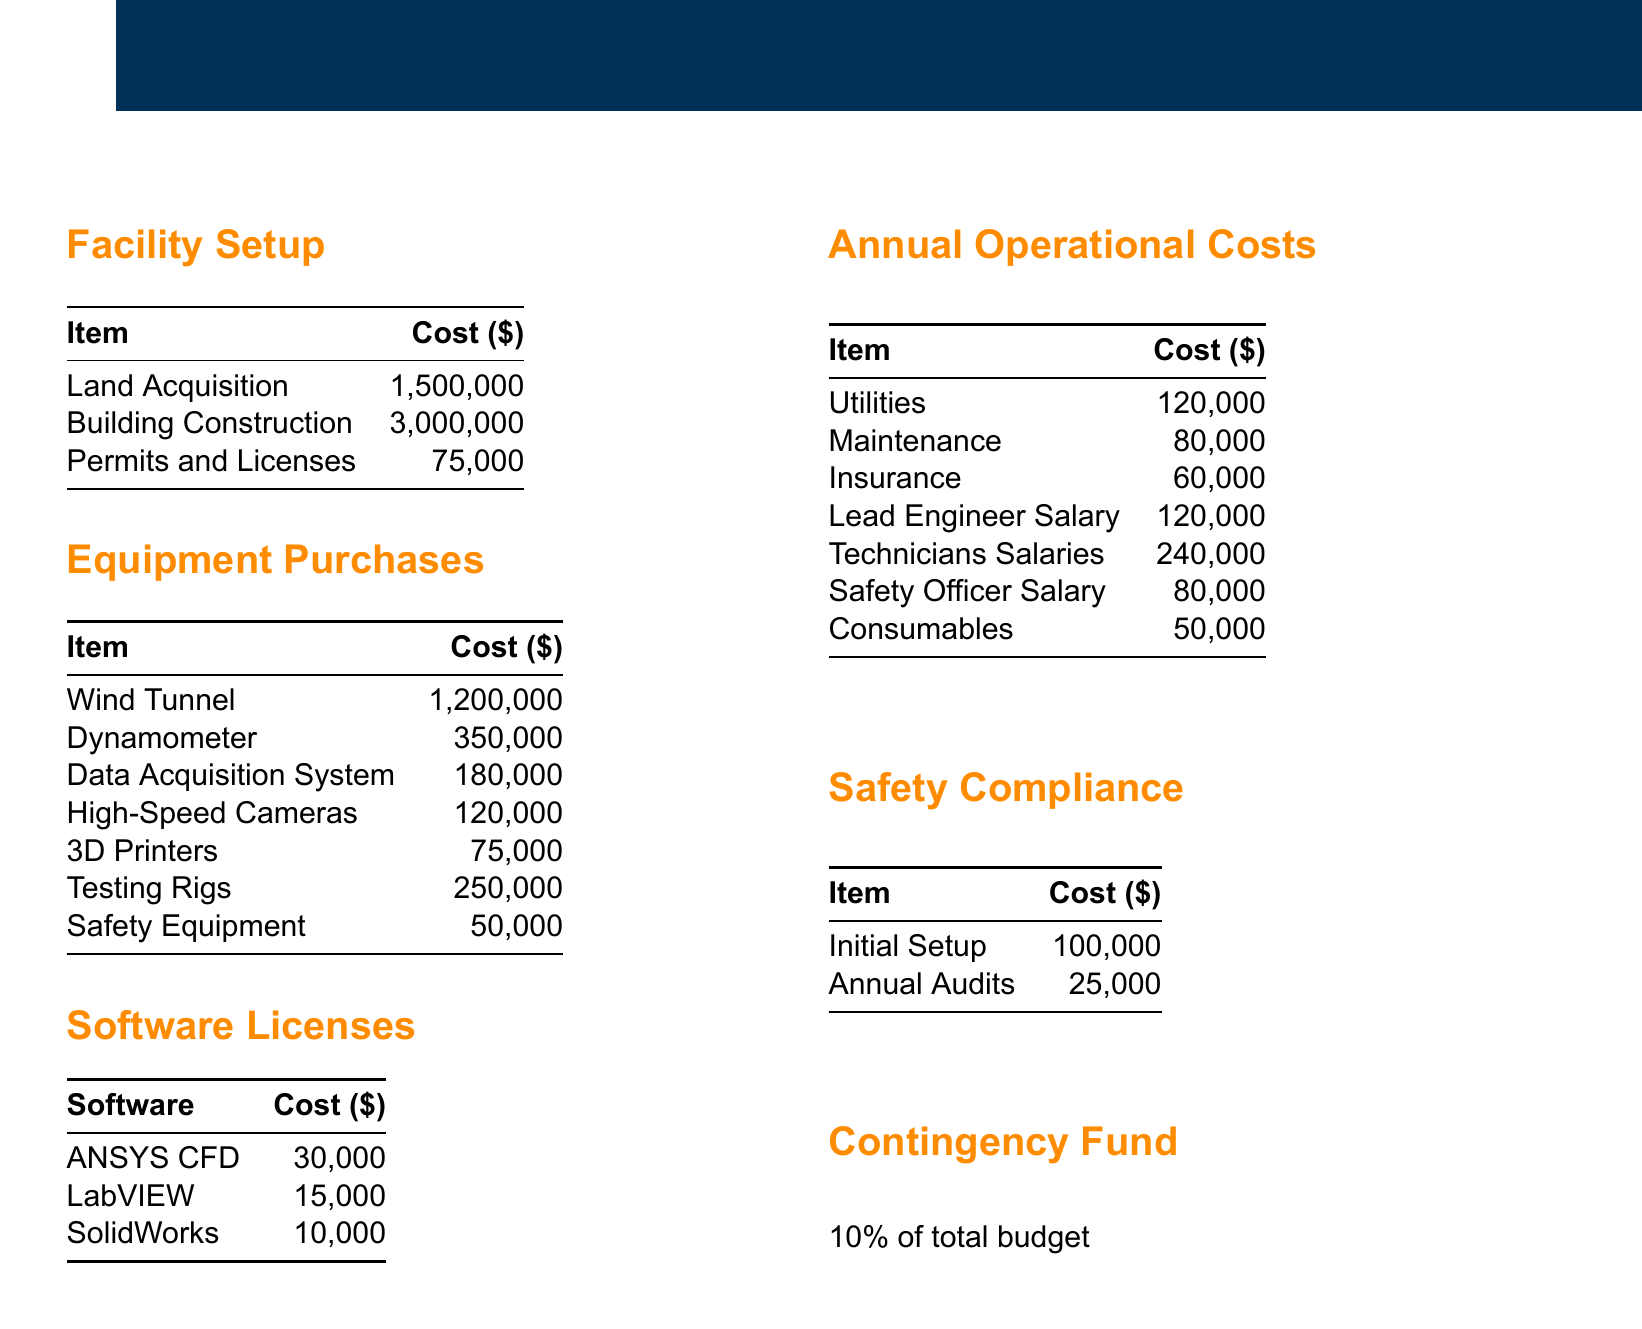What is the total cost for land acquisition? The document states the cost for land acquisition is one of the listed items, which is $1,500,000.
Answer: $1,500,000 What equipment costs the most? The highest cost in the Equipment Purchases section is the Wind Tunnel, which is listed with its cost.
Answer: $1,200,000 How much will safety audits cost annually? The document specifies that annual audits for safety compliance will cost $25,000.
Answer: $25,000 What is the sum of initial setup and annual audits for safety compliance? The initial setup costs $100,000 and annual audits cost $25,000. Summing these gives $100,000 + $25,000 = $125,000.
Answer: $125,000 What percentage of the total budget is allocated for the contingency fund? The document states that the contingency fund is 10% of the total budget.
Answer: 10% How much is allocated for Utilities annually? The document lists Utilities as an annual operational cost, which is $120,000.
Answer: $120,000 What is the total cost of software licenses? The document has three software licenses listed, summing to $30,000 + $15,000 + $10,000 = $55,000.
Answer: $55,000 What is the total cost for maintenance and insurance combined? Maintenance costs $80,000 and insurance costs $60,000, summed gives $80,000 + $60,000 = $140,000.
Answer: $140,000 What is the total initial setup cost for the facility? The total for facility setup includes land acquisition, building construction, and permits. Totaling these gives $1,500,000 + $3,000,000 + $75,000 = $4,575,000.
Answer: $4,575,000 